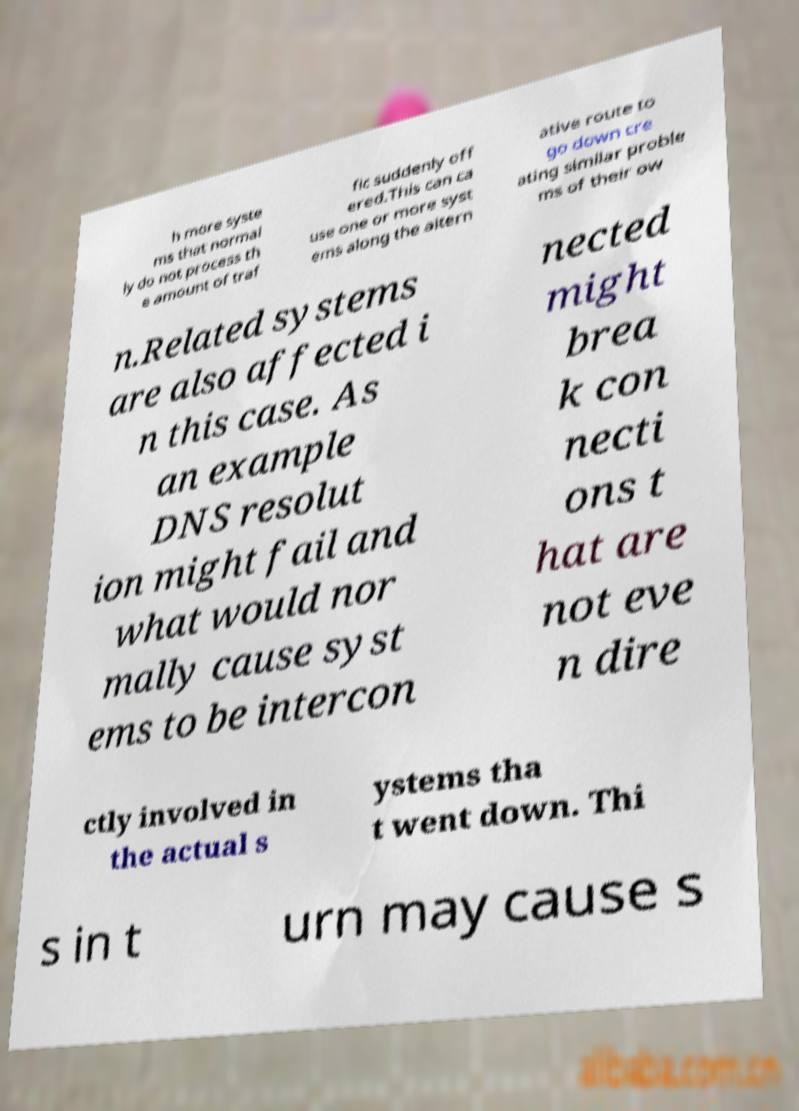Please read and relay the text visible in this image. What does it say? h more syste ms that normal ly do not process th e amount of traf fic suddenly off ered.This can ca use one or more syst ems along the altern ative route to go down cre ating similar proble ms of their ow n.Related systems are also affected i n this case. As an example DNS resolut ion might fail and what would nor mally cause syst ems to be intercon nected might brea k con necti ons t hat are not eve n dire ctly involved in the actual s ystems tha t went down. Thi s in t urn may cause s 